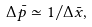Convert formula to latex. <formula><loc_0><loc_0><loc_500><loc_500>\Delta \bar { p } \simeq 1 / \Delta \bar { x } ,</formula> 